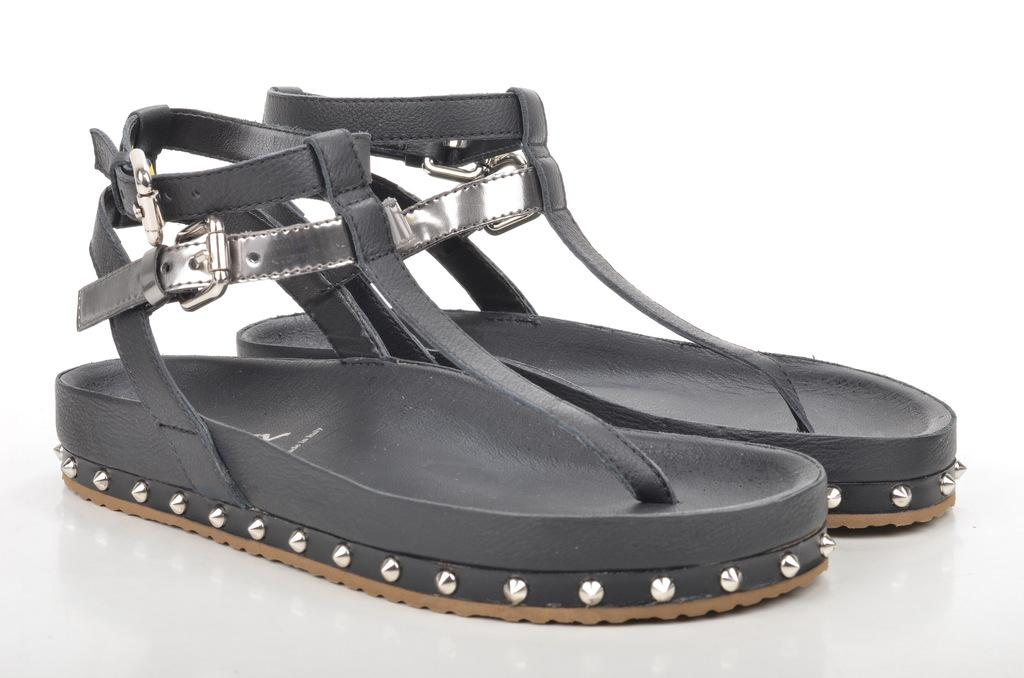What type of footwear is visible in the image? There are sandals in the image. What color are the sandals? The sandals are black in color. What is the color of the background in the image? The background of the image is white. Are there any trees visible in the image? There are no trees present in the image; it only features sandals and a white background. 